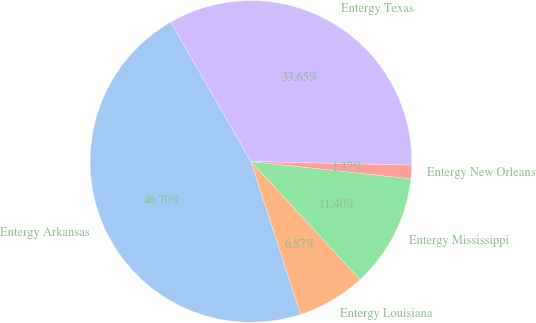Convert chart. <chart><loc_0><loc_0><loc_500><loc_500><pie_chart><fcel>Entergy Arkansas<fcel>Entergy Louisiana<fcel>Entergy Mississippi<fcel>Entergy New Orleans<fcel>Entergy Texas<nl><fcel>46.7%<fcel>6.87%<fcel>11.4%<fcel>1.37%<fcel>33.65%<nl></chart> 